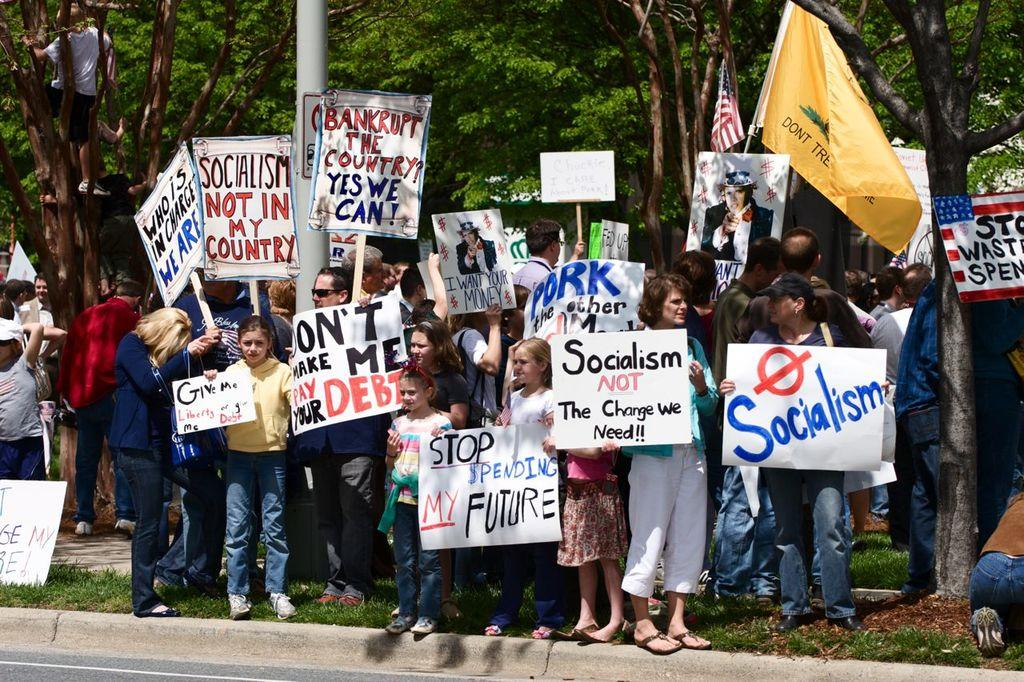How many people are present in the image? There are people in the image, but the exact number is not specified. What are some of the people holding in the image? Some of the people are holding placards with text and images in the image. What type of natural environment is visible in the image? Trees, grass, and a pole are visible in the image, suggesting a natural setting. What additional objects can be seen in the image? Flags are also present in the image. What type of calculator is being used by the person in the image? There is no calculator present in the image. What route are the people in the image following? The image does not show any specific route being followed by the people. 